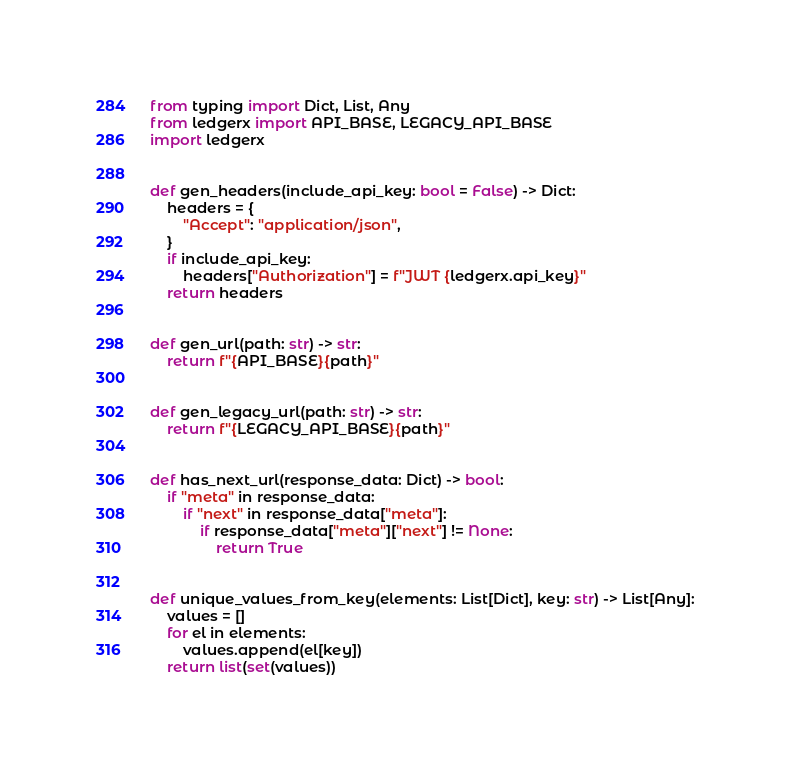Convert code to text. <code><loc_0><loc_0><loc_500><loc_500><_Python_>from typing import Dict, List, Any
from ledgerx import API_BASE, LEGACY_API_BASE
import ledgerx


def gen_headers(include_api_key: bool = False) -> Dict:
    headers = {
        "Accept": "application/json",
    }
    if include_api_key:
        headers["Authorization"] = f"JWT {ledgerx.api_key}"
    return headers


def gen_url(path: str) -> str:
    return f"{API_BASE}{path}"


def gen_legacy_url(path: str) -> str:
    return f"{LEGACY_API_BASE}{path}"


def has_next_url(response_data: Dict) -> bool:
    if "meta" in response_data:
        if "next" in response_data["meta"]:
            if response_data["meta"]["next"] != None:
                return True


def unique_values_from_key(elements: List[Dict], key: str) -> List[Any]:
    values = []
    for el in elements:
        values.append(el[key])
    return list(set(values))
</code> 